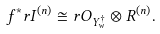<formula> <loc_0><loc_0><loc_500><loc_500>f ^ { \ast } r I ^ { ( n ) } \cong r O _ { Y ^ { \dag } _ { w } } \otimes R ^ { ( n ) } .</formula> 